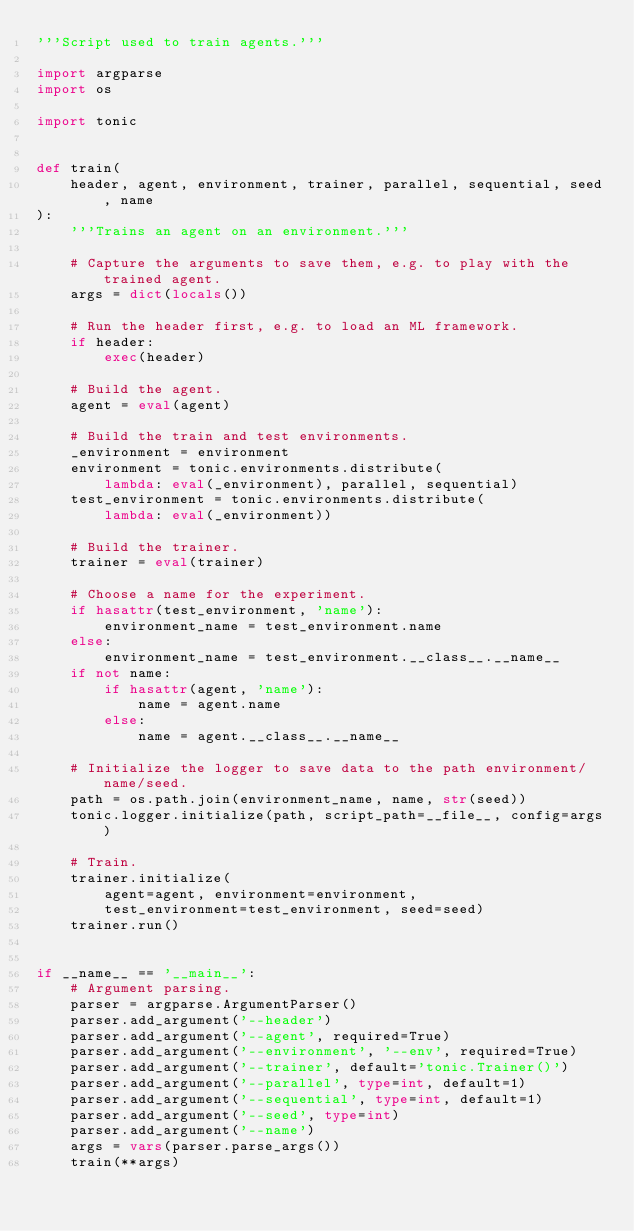<code> <loc_0><loc_0><loc_500><loc_500><_Python_>'''Script used to train agents.'''

import argparse
import os

import tonic


def train(
    header, agent, environment, trainer, parallel, sequential, seed, name
):
    '''Trains an agent on an environment.'''

    # Capture the arguments to save them, e.g. to play with the trained agent.
    args = dict(locals())

    # Run the header first, e.g. to load an ML framework.
    if header:
        exec(header)

    # Build the agent.
    agent = eval(agent)

    # Build the train and test environments.
    _environment = environment
    environment = tonic.environments.distribute(
        lambda: eval(_environment), parallel, sequential)
    test_environment = tonic.environments.distribute(
        lambda: eval(_environment))

    # Build the trainer.
    trainer = eval(trainer)

    # Choose a name for the experiment.
    if hasattr(test_environment, 'name'):
        environment_name = test_environment.name
    else:
        environment_name = test_environment.__class__.__name__
    if not name:
        if hasattr(agent, 'name'):
            name = agent.name
        else:
            name = agent.__class__.__name__

    # Initialize the logger to save data to the path environment/name/seed.
    path = os.path.join(environment_name, name, str(seed))
    tonic.logger.initialize(path, script_path=__file__, config=args)

    # Train.
    trainer.initialize(
        agent=agent, environment=environment,
        test_environment=test_environment, seed=seed)
    trainer.run()


if __name__ == '__main__':
    # Argument parsing.
    parser = argparse.ArgumentParser()
    parser.add_argument('--header')
    parser.add_argument('--agent', required=True)
    parser.add_argument('--environment', '--env', required=True)
    parser.add_argument('--trainer', default='tonic.Trainer()')
    parser.add_argument('--parallel', type=int, default=1)
    parser.add_argument('--sequential', type=int, default=1)
    parser.add_argument('--seed', type=int)
    parser.add_argument('--name')
    args = vars(parser.parse_args())
    train(**args)
</code> 